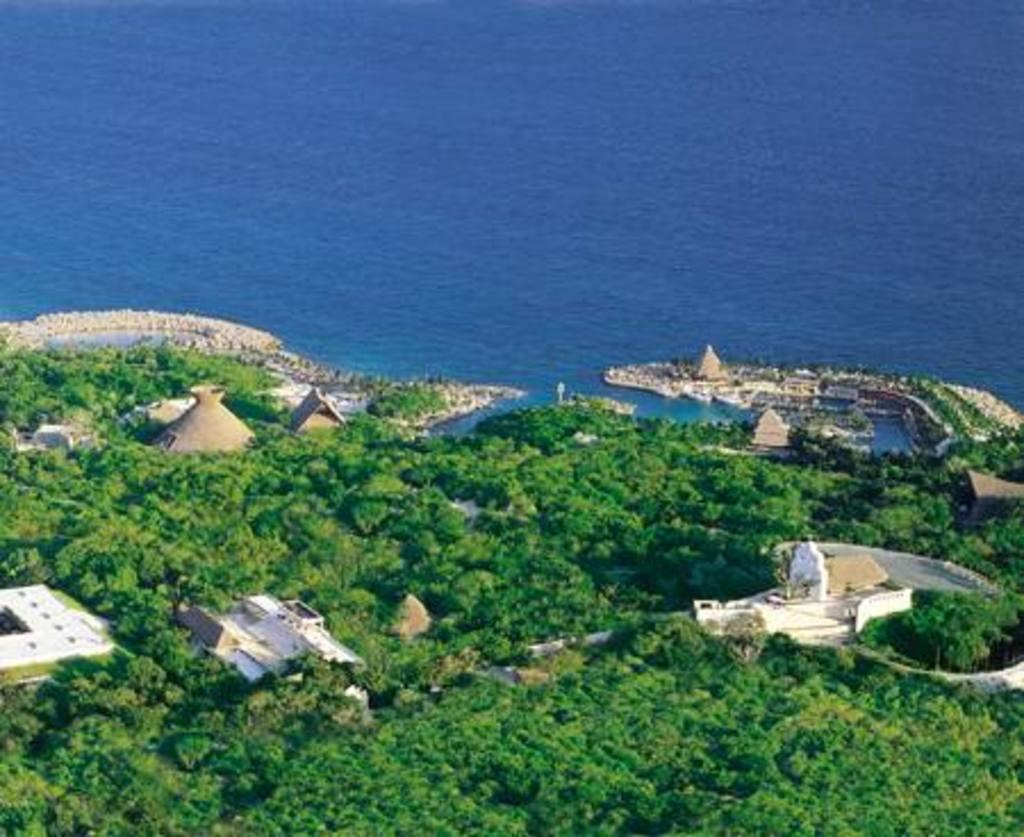What type of vegetation can be seen in the image? There are trees in the image. What type of structures are present in the image? There are houses in the image. What pathway is visible in the image? There is a walkway in the image. What natural element is visible in the image? There is water visible in the image. Can you tell me how many laborers are working on the trees in the image? There is no indication of laborers or any work being done on the trees in the image. What type of shade is provided by the trees in the image? The trees in the image do not provide any shade, as there is no reference to a specific type of shade. 